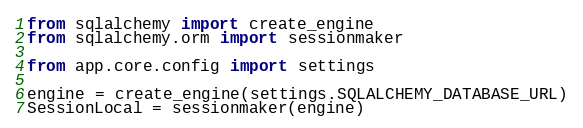<code> <loc_0><loc_0><loc_500><loc_500><_Python_>from sqlalchemy import create_engine
from sqlalchemy.orm import sessionmaker

from app.core.config import settings

engine = create_engine(settings.SQLALCHEMY_DATABASE_URL)
SessionLocal = sessionmaker(engine)
</code> 